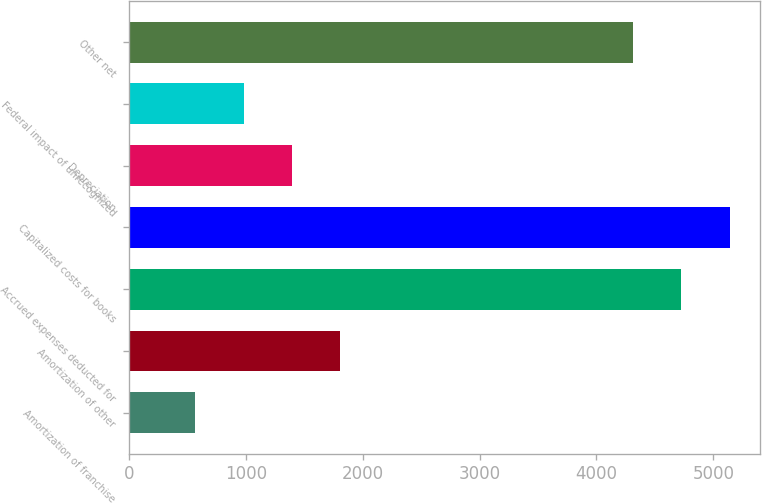Convert chart. <chart><loc_0><loc_0><loc_500><loc_500><bar_chart><fcel>Amortization of franchise<fcel>Amortization of other<fcel>Accrued expenses deducted for<fcel>Capitalized costs for books<fcel>Depreciation<fcel>Federal impact of unrecognized<fcel>Other net<nl><fcel>570<fcel>1806.9<fcel>4726.3<fcel>5138.6<fcel>1394.6<fcel>982.3<fcel>4314<nl></chart> 